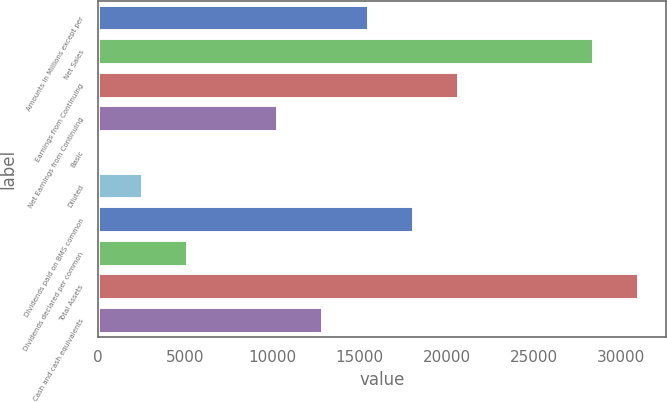Convert chart to OTSL. <chart><loc_0><loc_0><loc_500><loc_500><bar_chart><fcel>Amounts in Millions except per<fcel>Net Sales<fcel>Earnings from Continuing<fcel>Net Earnings from Continuing<fcel>Basic<fcel>Diluted<fcel>Dividends paid on BMS common<fcel>Dividends declared per common<fcel>Total Assets<fcel>Cash and cash equivalents<nl><fcel>15520.5<fcel>28453.7<fcel>20693.8<fcel>10347.2<fcel>0.65<fcel>2587.29<fcel>18107.1<fcel>5173.93<fcel>31040.3<fcel>12933.8<nl></chart> 